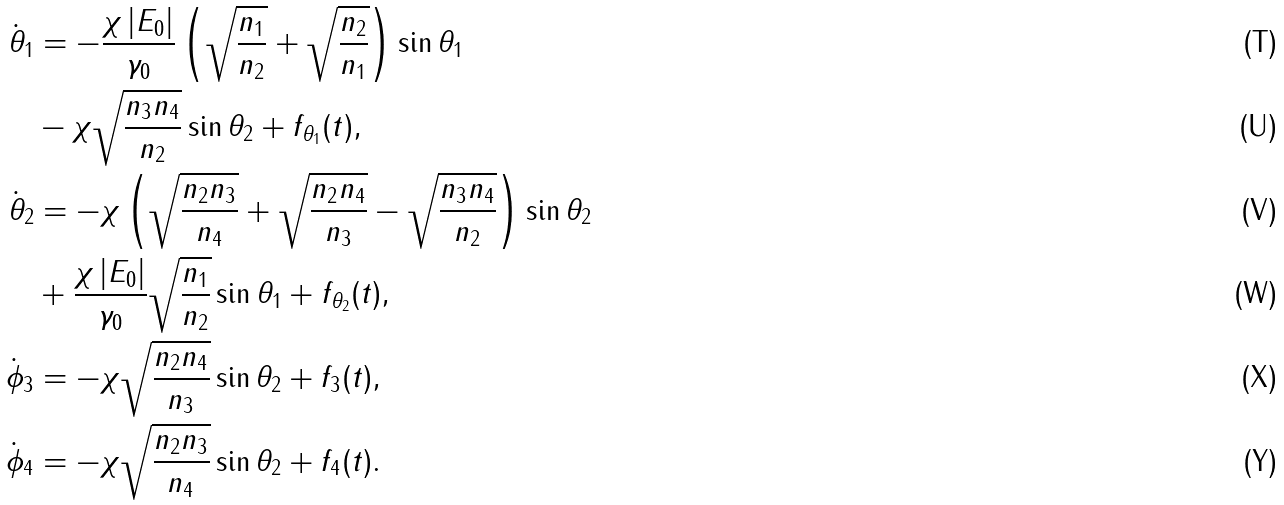Convert formula to latex. <formula><loc_0><loc_0><loc_500><loc_500>\dot { \theta } _ { 1 } & = - \frac { \chi \left | E _ { 0 } \right | } { \gamma _ { 0 } } \left ( \sqrt { \frac { n _ { 1 } } { n _ { 2 } } } + \sqrt { \frac { n _ { 2 } } { n _ { 1 } } } \right ) \sin \theta _ { 1 } \\ & - \chi \sqrt { \frac { n _ { 3 } n _ { 4 } } { n _ { 2 } } } \sin \theta _ { 2 } + f _ { \theta _ { 1 } } ( t ) , \\ \dot { \theta } _ { 2 } & = - \chi \left ( \sqrt { \frac { n _ { 2 } n _ { 3 } } { n _ { 4 } } } + \sqrt { \frac { n _ { 2 } n _ { 4 } } { n _ { 3 } } } - \sqrt { \frac { n _ { 3 } n _ { 4 } } { n _ { 2 } } } \right ) \sin \theta _ { 2 } \\ & + \frac { \chi \left | E _ { 0 } \right | } { \gamma _ { 0 } } \sqrt { \frac { n _ { 1 } } { n _ { 2 } } } \sin \theta _ { 1 } + f _ { \theta _ { 2 } } ( t ) , \\ \dot { \phi } _ { 3 } & = - \chi \sqrt { \frac { n _ { 2 } n _ { 4 } } { n _ { 3 } } } \sin \theta _ { 2 } + f _ { 3 } ( t ) , \\ \dot { \phi } _ { 4 } & = - \chi \sqrt { \frac { n _ { 2 } n _ { 3 } } { n _ { 4 } } } \sin \theta _ { 2 } + f _ { 4 } ( t ) .</formula> 